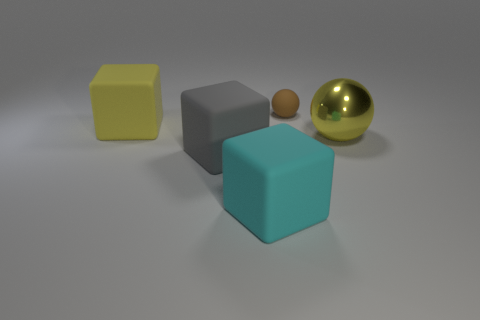Is there any other thing that has the same material as the large sphere?
Make the answer very short. No. How many things are big rubber blocks on the right side of the big yellow block or big gray matte things?
Your answer should be very brief. 2. There is a sphere that is the same material as the cyan block; what size is it?
Make the answer very short. Small. Is the number of shiny things that are left of the tiny brown matte object greater than the number of large metal spheres?
Offer a terse response. No. Does the cyan thing have the same shape as the yellow thing that is to the left of the cyan object?
Offer a terse response. Yes. What number of large objects are either metal balls or brown balls?
Give a very brief answer. 1. There is a block that is the same color as the big sphere; what size is it?
Keep it short and to the point. Large. There is a sphere that is behind the big thing behind the yellow metal sphere; what is its color?
Ensure brevity in your answer.  Brown. Do the tiny ball and the big yellow object that is on the right side of the large yellow cube have the same material?
Your answer should be compact. No. There is a object that is on the right side of the rubber ball; what material is it?
Give a very brief answer. Metal. 